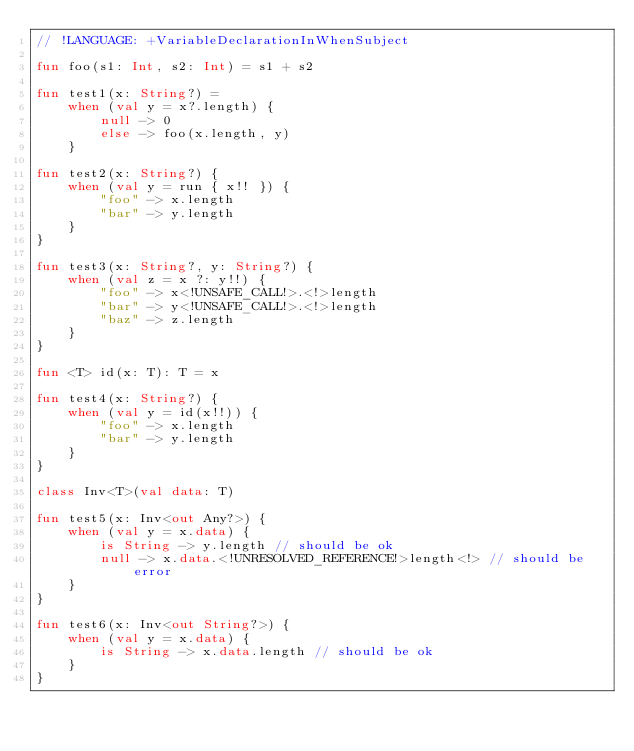<code> <loc_0><loc_0><loc_500><loc_500><_Kotlin_>// !LANGUAGE: +VariableDeclarationInWhenSubject

fun foo(s1: Int, s2: Int) = s1 + s2

fun test1(x: String?) =
    when (val y = x?.length) {
        null -> 0
        else -> foo(x.length, y)
    }

fun test2(x: String?) {
    when (val y = run { x!! }) {
        "foo" -> x.length
        "bar" -> y.length
    }
}

fun test3(x: String?, y: String?) {
    when (val z = x ?: y!!) {
        "foo" -> x<!UNSAFE_CALL!>.<!>length
        "bar" -> y<!UNSAFE_CALL!>.<!>length
        "baz" -> z.length
    }
}

fun <T> id(x: T): T = x

fun test4(x: String?) {
    when (val y = id(x!!)) {
        "foo" -> x.length
        "bar" -> y.length
    }
}

class Inv<T>(val data: T)

fun test5(x: Inv<out Any?>) {
    when (val y = x.data) {
        is String -> y.length // should be ok
        null -> x.data.<!UNRESOLVED_REFERENCE!>length<!> // should be error
    }
}

fun test6(x: Inv<out String?>) {
    when (val y = x.data) {
        is String -> x.data.length // should be ok
    }
}</code> 